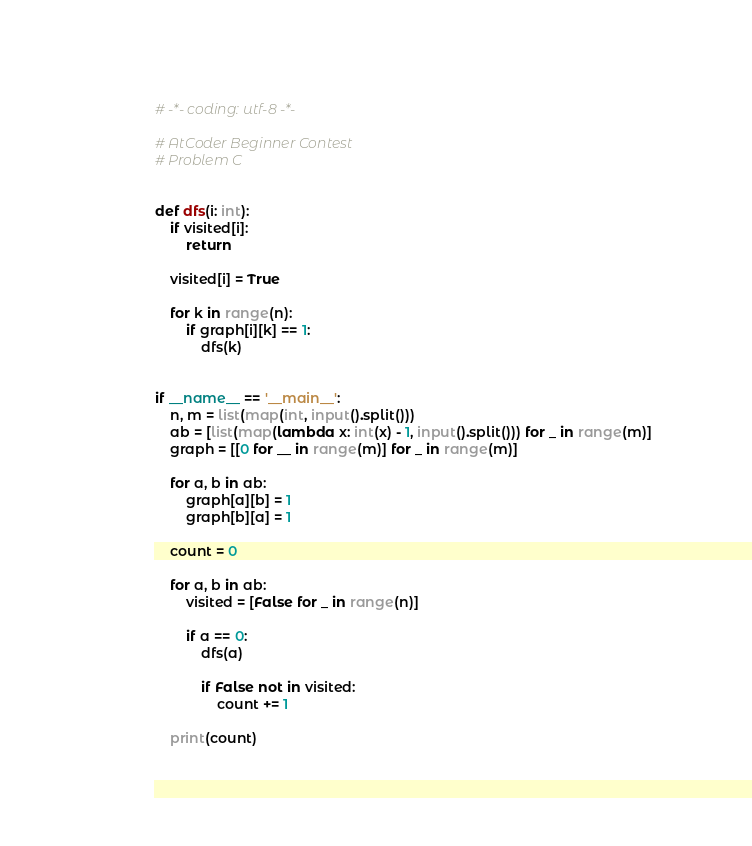<code> <loc_0><loc_0><loc_500><loc_500><_Python_># -*- coding: utf-8 -*-

# AtCoder Beginner Contest
# Problem C


def dfs(i: int):
    if visited[i]:
        return

    visited[i] = True

    for k in range(n):
        if graph[i][k] == 1:
            dfs(k)


if __name__ == '__main__':
    n, m = list(map(int, input().split()))
    ab = [list(map(lambda x: int(x) - 1, input().split())) for _ in range(m)]
    graph = [[0 for __ in range(m)] for _ in range(m)]

    for a, b in ab:
        graph[a][b] = 1
        graph[b][a] = 1

    count = 0

    for a, b in ab:
        visited = [False for _ in range(n)]

        if a == 0:
            dfs(a)

            if False not in visited:
                count += 1

    print(count)
</code> 